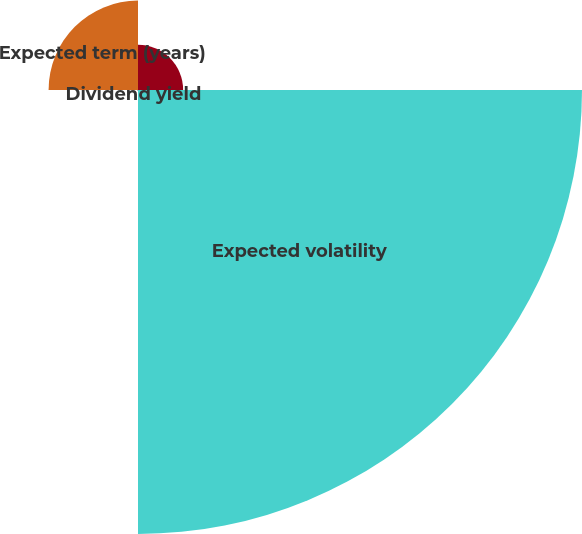Convert chart to OTSL. <chart><loc_0><loc_0><loc_500><loc_500><pie_chart><fcel>Risk-free interest rate<fcel>Expected volatility<fcel>Dividend yield<fcel>Expected term (years)<nl><fcel>7.79%<fcel>76.63%<fcel>0.15%<fcel>15.43%<nl></chart> 